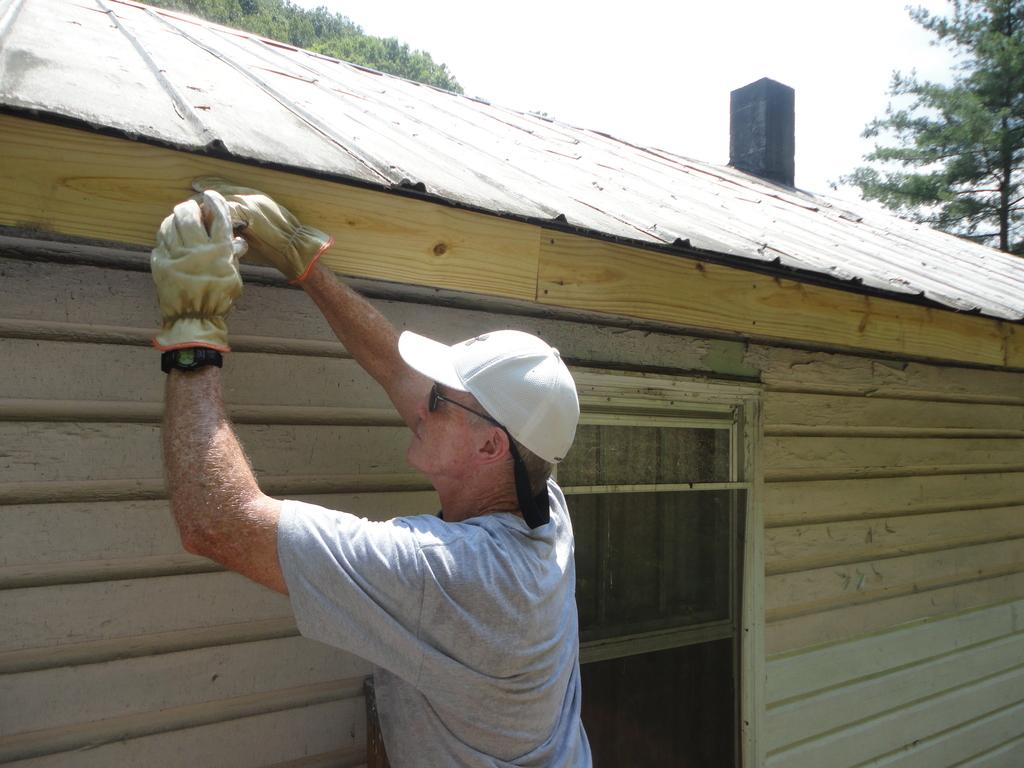What is the main subject of the image? There is a person standing near a house in the image. Can you describe the background of the image? There are trees in the background of the image. What type of hydrant is visible in the image? There is no hydrant present in the image. What type of flight is the person taking in the image? There is no flight or indication of travel in the image. 